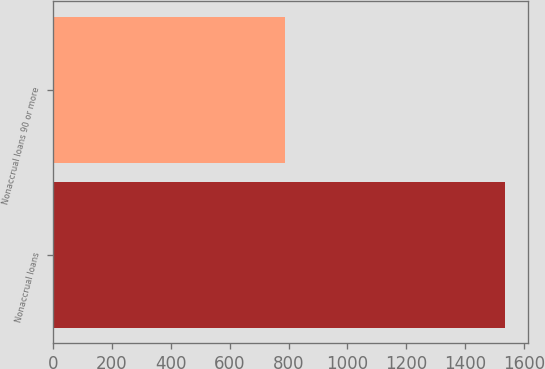Convert chart. <chart><loc_0><loc_0><loc_500><loc_500><bar_chart><fcel>Nonaccrual loans<fcel>Nonaccrual loans 90 or more<nl><fcel>1536<fcel>787<nl></chart> 